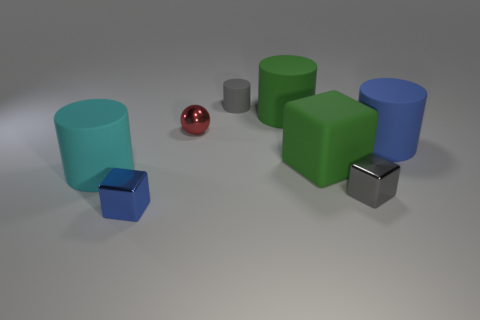What number of things are either blue rubber objects or large matte cylinders on the right side of the small matte cylinder?
Give a very brief answer. 2. There is a small thing that is the same color as the small cylinder; what shape is it?
Ensure brevity in your answer.  Cube. What number of other shiny spheres have the same size as the red metallic ball?
Give a very brief answer. 0. What number of green objects are either tiny objects or small blocks?
Make the answer very short. 0. There is a blue shiny object that is to the right of the large rubber cylinder that is to the left of the tiny red metallic object; what shape is it?
Keep it short and to the point. Cube. The blue thing that is the same size as the shiny ball is what shape?
Offer a terse response. Cube. Are there any matte objects of the same color as the large block?
Ensure brevity in your answer.  Yes. Is the number of cyan cylinders to the left of the large green matte cylinder the same as the number of blue cubes that are behind the gray metallic cube?
Your answer should be very brief. No. There is a red thing; is it the same shape as the tiny gray thing that is behind the green matte cylinder?
Provide a short and direct response. No. How many other things are made of the same material as the large green block?
Your answer should be very brief. 4. 